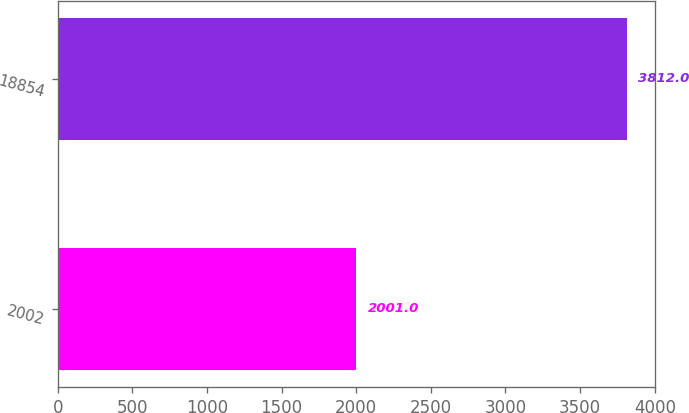Convert chart. <chart><loc_0><loc_0><loc_500><loc_500><bar_chart><fcel>2002<fcel>18854<nl><fcel>2001<fcel>3812<nl></chart> 